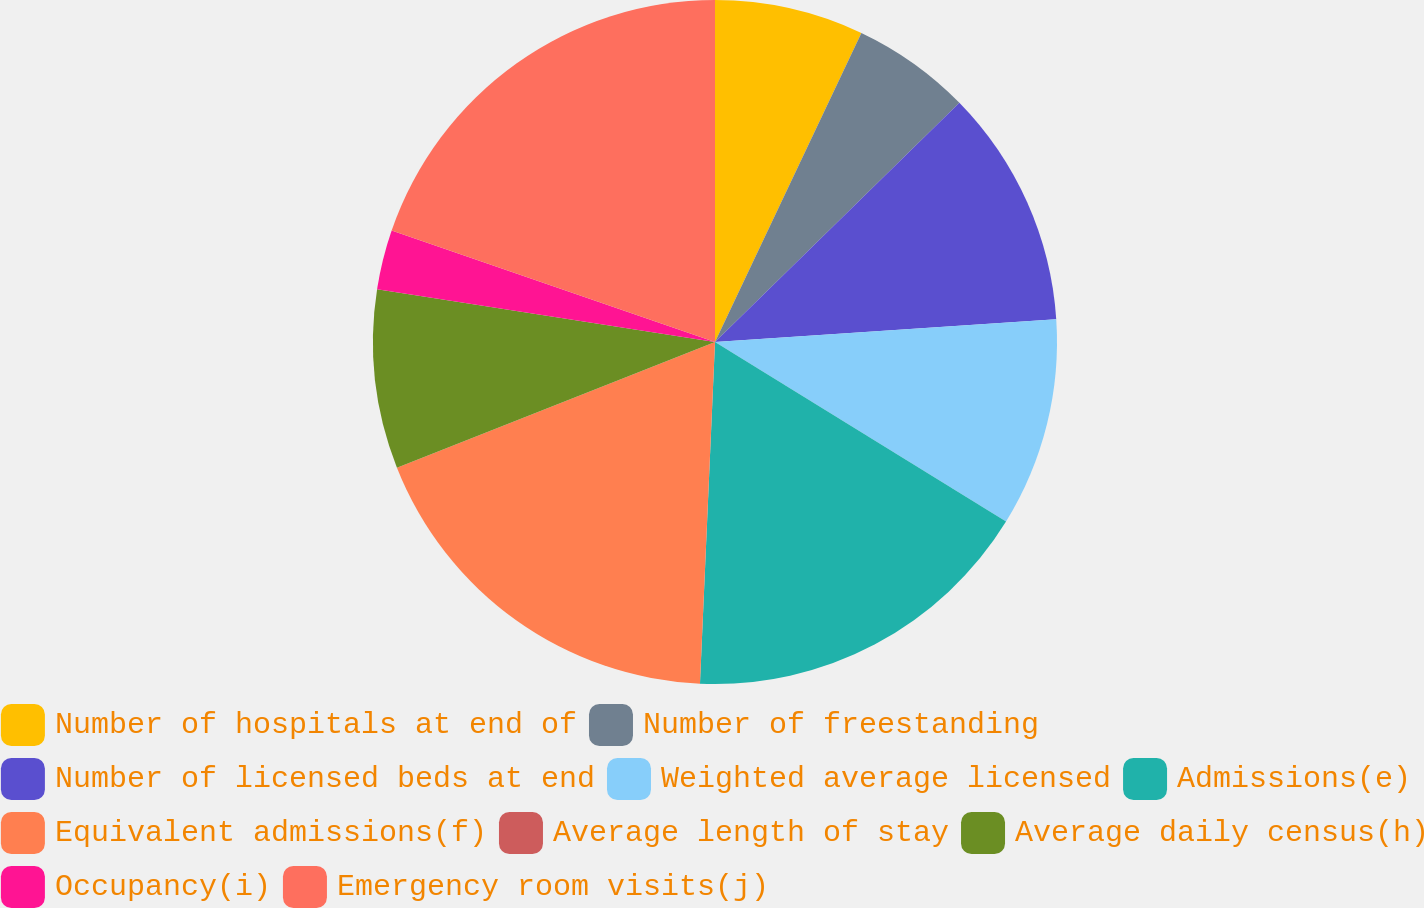Convert chart to OTSL. <chart><loc_0><loc_0><loc_500><loc_500><pie_chart><fcel>Number of hospitals at end of<fcel>Number of freestanding<fcel>Number of licensed beds at end<fcel>Weighted average licensed<fcel>Admissions(e)<fcel>Equivalent admissions(f)<fcel>Average length of stay<fcel>Average daily census(h)<fcel>Occupancy(i)<fcel>Emergency room visits(j)<nl><fcel>7.04%<fcel>5.63%<fcel>11.27%<fcel>9.86%<fcel>16.9%<fcel>18.31%<fcel>0.0%<fcel>8.45%<fcel>2.82%<fcel>19.72%<nl></chart> 